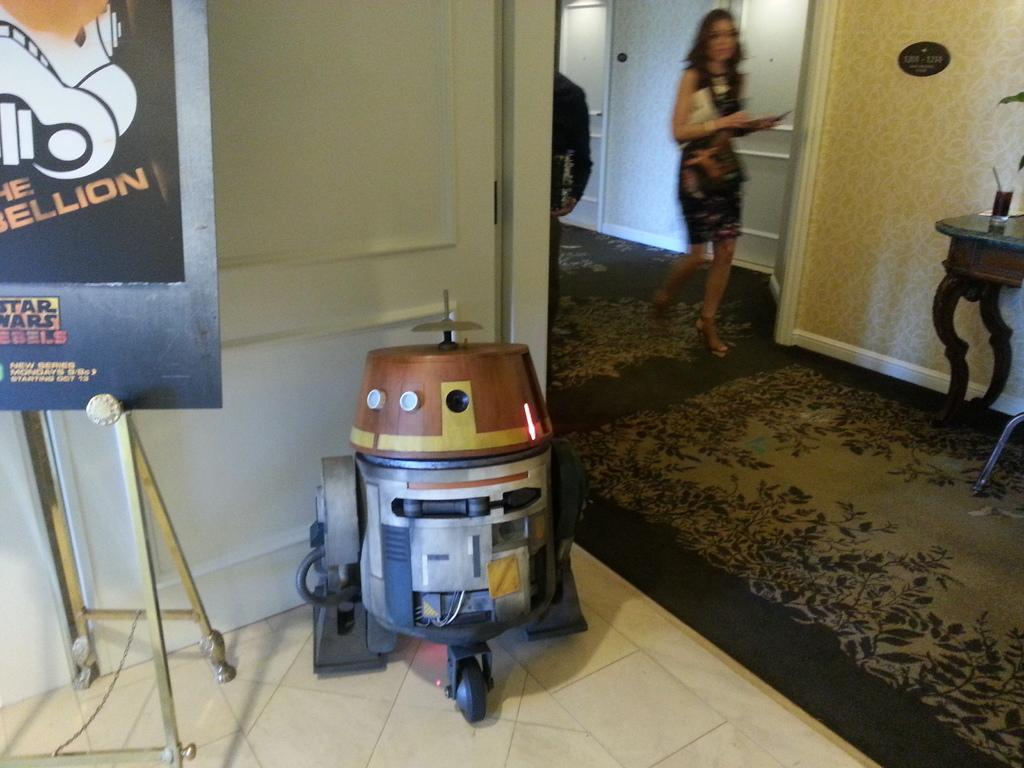<image>
Relay a brief, clear account of the picture shown. A poster advertising the Star Wars Rebels movie 